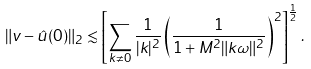<formula> <loc_0><loc_0><loc_500><loc_500>\| v - \hat { u } ( 0 ) \| _ { 2 } \lesssim \left [ \sum _ { k \neq 0 } \frac { 1 } { | k | ^ { 2 } } \left ( \frac { 1 } { 1 + M ^ { 2 } \| k \omega \| ^ { 2 } } \right ) ^ { 2 } \right ] ^ { \frac { 1 } { 2 } } .</formula> 